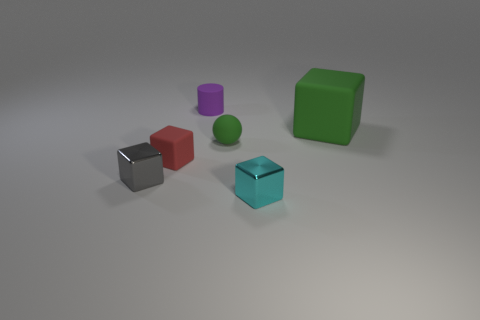There is a block that is the same color as the tiny matte sphere; what is its size?
Provide a short and direct response. Large. Is the shape of the tiny red thing the same as the small gray metal thing?
Your answer should be compact. Yes. There is a shiny object that is in front of the gray block; what size is it?
Provide a short and direct response. Small. There is a cyan shiny object; is it the same size as the object that is behind the green cube?
Offer a terse response. Yes. Is the number of purple rubber cylinders that are in front of the tiny gray metallic object less than the number of tiny brown things?
Give a very brief answer. No. What material is the small red object that is the same shape as the big green thing?
Provide a short and direct response. Rubber. There is a small matte thing that is left of the green rubber ball and in front of the purple matte thing; what shape is it?
Your answer should be very brief. Cube. What shape is the large green object that is made of the same material as the small cylinder?
Your answer should be very brief. Cube. What is the block to the right of the tiny cyan block made of?
Your response must be concise. Rubber. Do the gray cube in front of the tiny red matte block and the ball that is to the right of the small purple matte cylinder have the same size?
Your answer should be compact. Yes. 